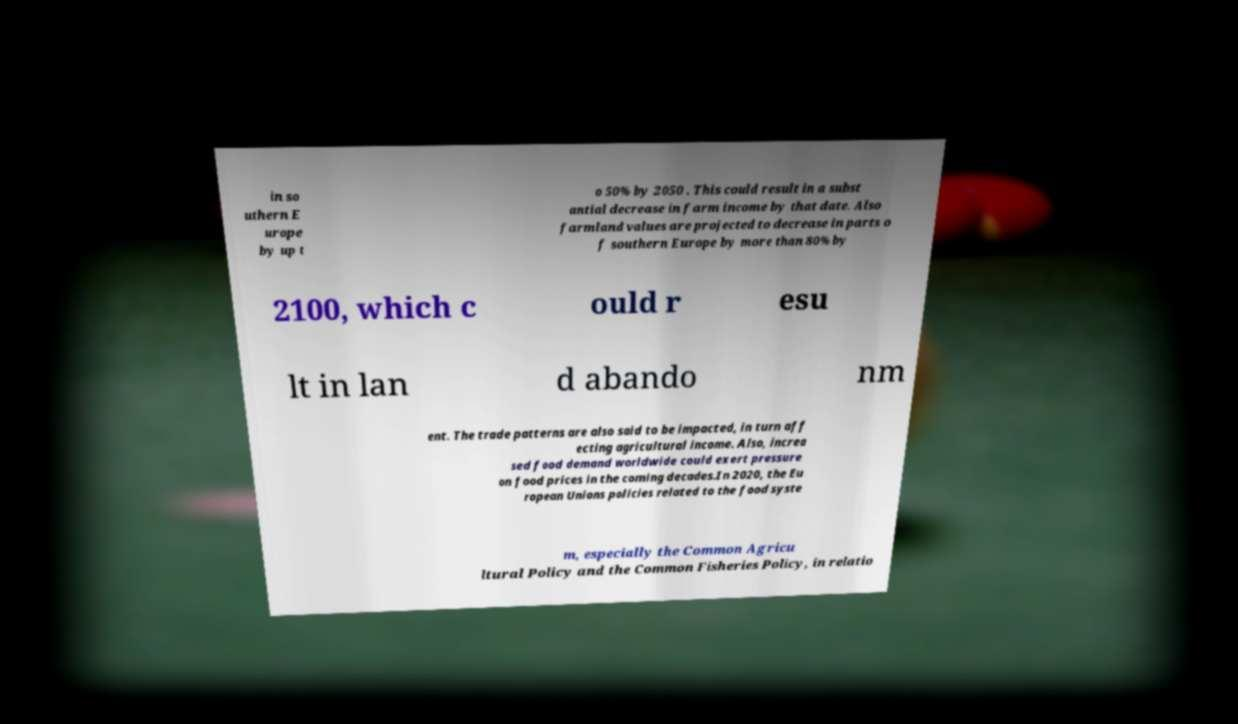For documentation purposes, I need the text within this image transcribed. Could you provide that? in so uthern E urope by up t o 50% by 2050 . This could result in a subst antial decrease in farm income by that date. Also farmland values are projected to decrease in parts o f southern Europe by more than 80% by 2100, which c ould r esu lt in lan d abando nm ent. The trade patterns are also said to be impacted, in turn aff ecting agricultural income. Also, increa sed food demand worldwide could exert pressure on food prices in the coming decades.In 2020, the Eu ropean Unions policies related to the food syste m, especially the Common Agricu ltural Policy and the Common Fisheries Policy, in relatio 